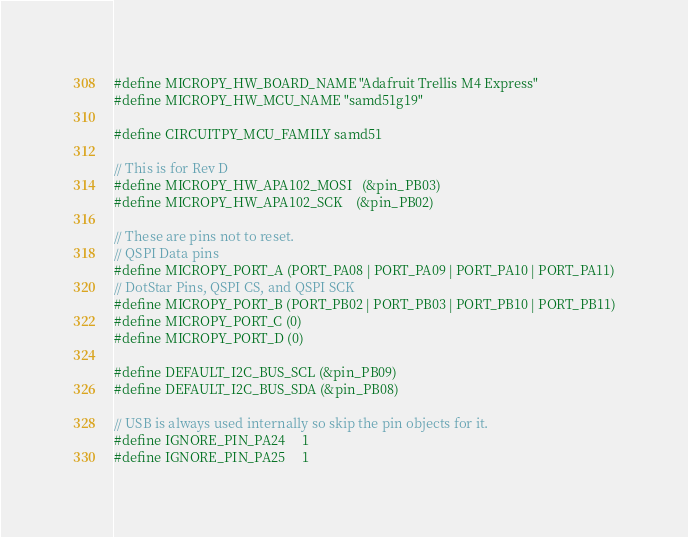<code> <loc_0><loc_0><loc_500><loc_500><_C_>
#define MICROPY_HW_BOARD_NAME "Adafruit Trellis M4 Express"
#define MICROPY_HW_MCU_NAME "samd51g19"

#define CIRCUITPY_MCU_FAMILY samd51

// This is for Rev D
#define MICROPY_HW_APA102_MOSI   (&pin_PB03)
#define MICROPY_HW_APA102_SCK    (&pin_PB02)

// These are pins not to reset.
// QSPI Data pins
#define MICROPY_PORT_A (PORT_PA08 | PORT_PA09 | PORT_PA10 | PORT_PA11)
// DotStar Pins, QSPI CS, and QSPI SCK
#define MICROPY_PORT_B (PORT_PB02 | PORT_PB03 | PORT_PB10 | PORT_PB11)
#define MICROPY_PORT_C (0)
#define MICROPY_PORT_D (0)

#define DEFAULT_I2C_BUS_SCL (&pin_PB09)
#define DEFAULT_I2C_BUS_SDA (&pin_PB08)

// USB is always used internally so skip the pin objects for it.
#define IGNORE_PIN_PA24     1
#define IGNORE_PIN_PA25     1
</code> 